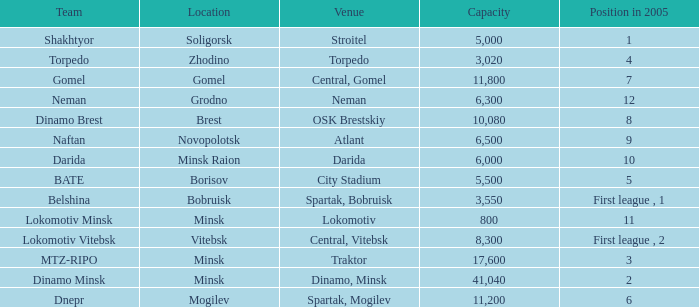Can you tell me the Venue that has the Position in 2005 of 8? OSK Brestskiy. 